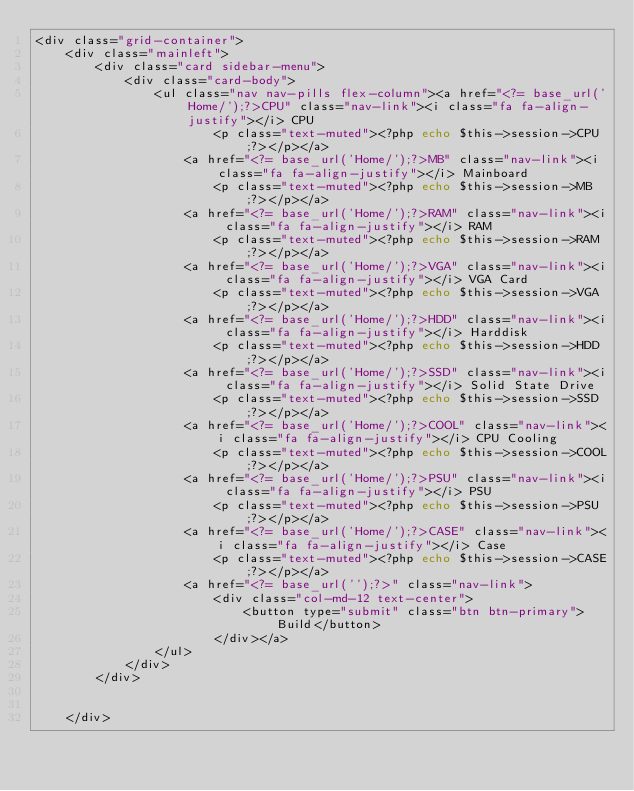Convert code to text. <code><loc_0><loc_0><loc_500><loc_500><_PHP_><div class="grid-container">
    <div class="mainleft">
        <div class="card sidebar-menu">
            <div class="card-body">
                <ul class="nav nav-pills flex-column"><a href="<?= base_url('Home/');?>CPU" class="nav-link"><i class="fa fa-align-justify"></i> CPU
                        <p class="text-muted"><?php echo $this->session->CPU;?></p></a>
                    <a href="<?= base_url('Home/');?>MB" class="nav-link"><i class="fa fa-align-justify"></i> Mainboard
                        <p class="text-muted"><?php echo $this->session->MB;?></p></a>
                    <a href="<?= base_url('Home/');?>RAM" class="nav-link"><i class="fa fa-align-justify"></i> RAM
                        <p class="text-muted"><?php echo $this->session->RAM;?></p></a>
                    <a href="<?= base_url('Home/');?>VGA" class="nav-link"><i class="fa fa-align-justify"></i> VGA Card
                        <p class="text-muted"><?php echo $this->session->VGA;?></p></a>
                    <a href="<?= base_url('Home/');?>HDD" class="nav-link"><i class="fa fa-align-justify"></i> Harddisk
                        <p class="text-muted"><?php echo $this->session->HDD;?></p></a>
                    <a href="<?= base_url('Home/');?>SSD" class="nav-link"><i class="fa fa-align-justify"></i> Solid State Drive
                        <p class="text-muted"><?php echo $this->session->SSD;?></p></a>
                    <a href="<?= base_url('Home/');?>COOL" class="nav-link"><i class="fa fa-align-justify"></i> CPU Cooling
                        <p class="text-muted"><?php echo $this->session->COOL;?></p></a>
                    <a href="<?= base_url('Home/');?>PSU" class="nav-link"><i class="fa fa-align-justify"></i> PSU
                        <p class="text-muted"><?php echo $this->session->PSU;?></p></a>
                    <a href="<?= base_url('Home/');?>CASE" class="nav-link"><i class="fa fa-align-justify"></i> Case
                        <p class="text-muted"><?php echo $this->session->CASE;?></p></a>
                    <a href="<?= base_url('');?>" class="nav-link">
                        <div class="col-md-12 text-center">
                            <button type="submit" class="btn btn-primary">Build</button>
                        </div></a>
                </ul>
            </div>
        </div>


    </div>



</code> 